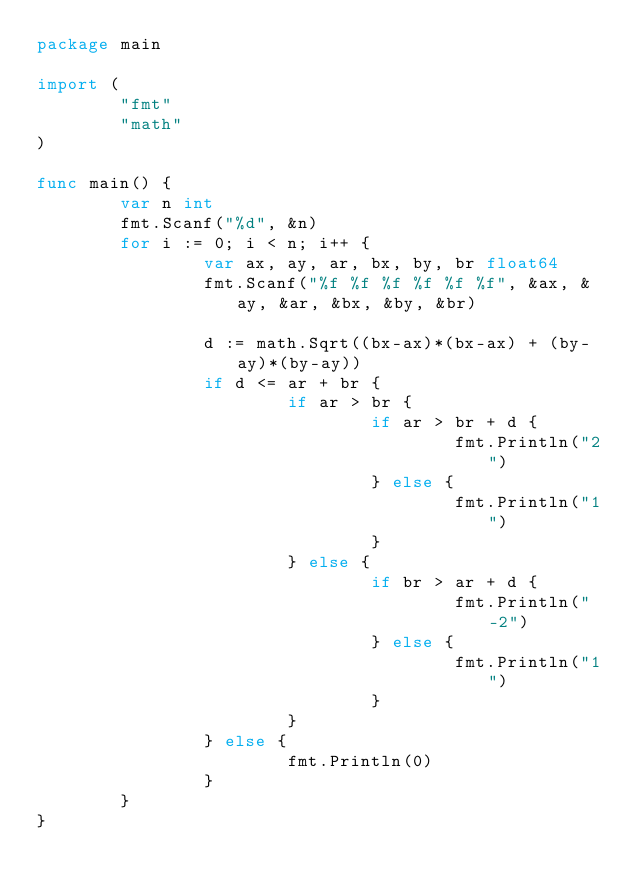<code> <loc_0><loc_0><loc_500><loc_500><_Go_>package main

import (
        "fmt"
        "math"
)

func main() {
        var n int
        fmt.Scanf("%d", &n)
        for i := 0; i < n; i++ {
                var ax, ay, ar, bx, by, br float64
                fmt.Scanf("%f %f %f %f %f %f", &ax, &ay, &ar, &bx, &by, &br)

                d := math.Sqrt((bx-ax)*(bx-ax) + (by-ay)*(by-ay))
                if d <= ar + br {
                        if ar > br {
                                if ar > br + d {
                                        fmt.Println("2")
                                } else {
                                        fmt.Println("1")
                                }
                        } else {
                                if br > ar + d {
                                        fmt.Println("-2")
                                } else {
                                        fmt.Println("1")
                                }
                        }
                } else {
                        fmt.Println(0)
                }
        }
}

</code> 